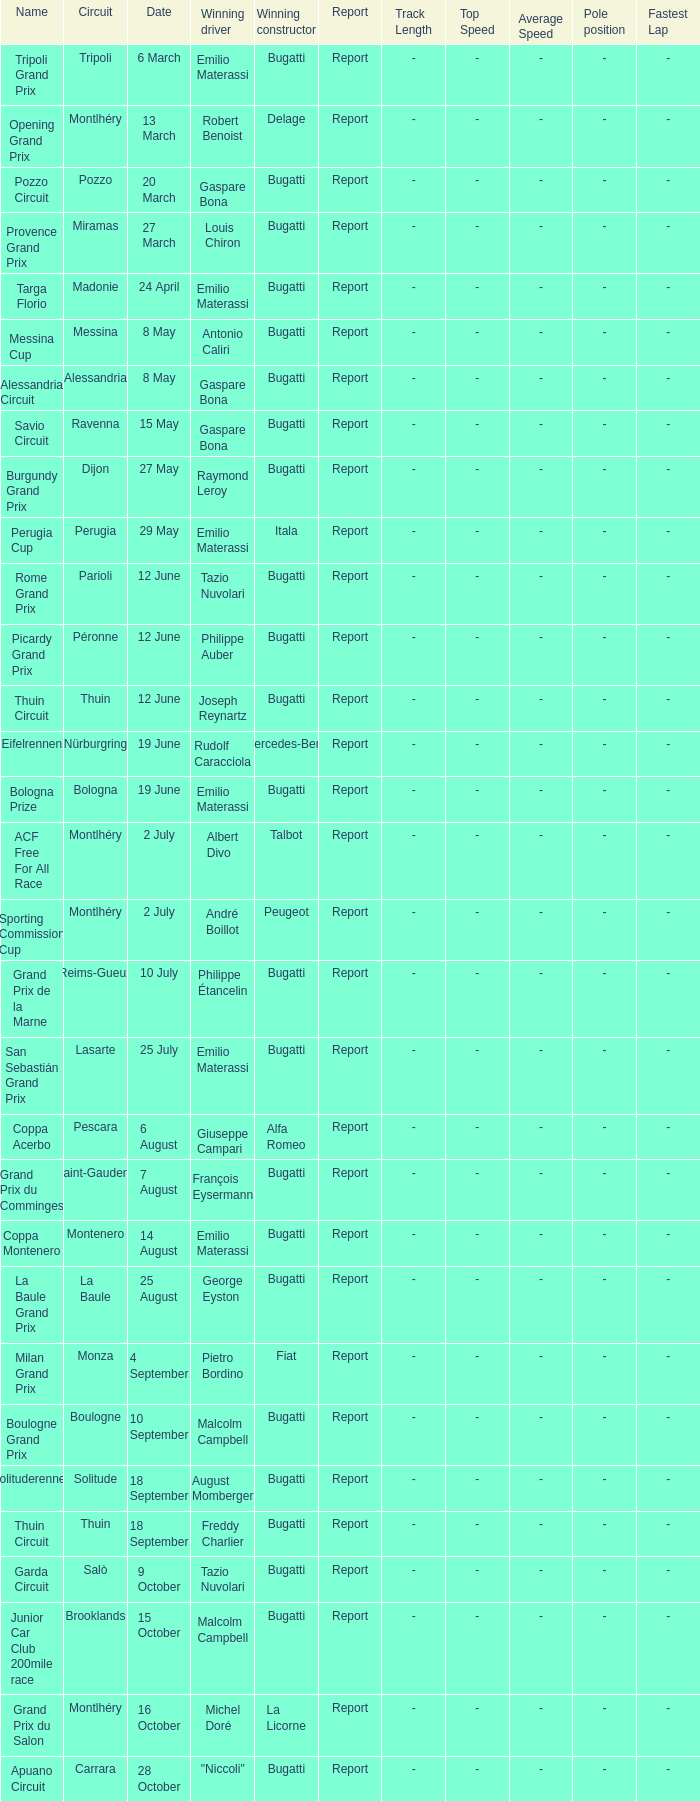Parse the full table. {'header': ['Name', 'Circuit', 'Date', 'Winning driver', 'Winning constructor', 'Report', 'Track Length', 'Top Speed', 'Average Speed', 'Pole position', 'Fastest Lap'], 'rows': [['Tripoli Grand Prix', 'Tripoli', '6 March', 'Emilio Materassi', 'Bugatti', 'Report', '-', '-', '-', '-', '-'], ['Opening Grand Prix', 'Montlhéry', '13 March', 'Robert Benoist', 'Delage', 'Report', '-', '-', '-', '-', '-'], ['Pozzo Circuit', 'Pozzo', '20 March', 'Gaspare Bona', 'Bugatti', 'Report', '-', '-', '-', '-', '-'], ['Provence Grand Prix', 'Miramas', '27 March', 'Louis Chiron', 'Bugatti', 'Report', '-', '-', '-', '-', '-'], ['Targa Florio', 'Madonie', '24 April', 'Emilio Materassi', 'Bugatti', 'Report', '-', '-', '-', '-', '-'], ['Messina Cup', 'Messina', '8 May', 'Antonio Caliri', 'Bugatti', 'Report', '-', '-', '-', '-', '-'], ['Alessandria Circuit', 'Alessandria', '8 May', 'Gaspare Bona', 'Bugatti', 'Report', '-', '-', '-', '-', '-'], ['Savio Circuit', 'Ravenna', '15 May', 'Gaspare Bona', 'Bugatti', 'Report', '-', '-', '-', '-', '-'], ['Burgundy Grand Prix', 'Dijon', '27 May', 'Raymond Leroy', 'Bugatti', 'Report', '-', '-', '-', '-', '-'], ['Perugia Cup', 'Perugia', '29 May', 'Emilio Materassi', 'Itala', 'Report', '-', '-', '-', '-', '-'], ['Rome Grand Prix', 'Parioli', '12 June', 'Tazio Nuvolari', 'Bugatti', 'Report', '-', '-', '-', '-', '-'], ['Picardy Grand Prix', 'Péronne', '12 June', 'Philippe Auber', 'Bugatti', 'Report', '-', '-', '-', '-', '-'], ['Thuin Circuit', 'Thuin', '12 June', 'Joseph Reynartz', 'Bugatti', 'Report', '-', '-', '-', '-', '-'], ['Eifelrennen', 'Nürburgring', '19 June', 'Rudolf Caracciola', 'Mercedes-Benz', 'Report', '-', '-', '-', '-', '-'], ['Bologna Prize', 'Bologna', '19 June', 'Emilio Materassi', 'Bugatti', 'Report', '-', '-', '-', '-', '-'], ['ACF Free For All Race', 'Montlhéry', '2 July', 'Albert Divo', 'Talbot', 'Report', '-', '-', '-', '-', '-'], ['Sporting Commission Cup', 'Montlhéry', '2 July', 'André Boillot', 'Peugeot', 'Report', '-', '-', '-', '-', '-'], ['Grand Prix de la Marne', 'Reims-Gueux', '10 July', 'Philippe Étancelin', 'Bugatti', 'Report', '-', '-', '-', '-', '-'], ['San Sebastián Grand Prix', 'Lasarte', '25 July', 'Emilio Materassi', 'Bugatti', 'Report', '-', '-', '-', '-', '-'], ['Coppa Acerbo', 'Pescara', '6 August', 'Giuseppe Campari', 'Alfa Romeo', 'Report', '-', '-', '-', '-', '-'], ['Grand Prix du Comminges', 'Saint-Gaudens', '7 August', 'François Eysermann', 'Bugatti', 'Report', '-', '-', '-', '-', '-'], ['Coppa Montenero', 'Montenero', '14 August', 'Emilio Materassi', 'Bugatti', 'Report', '-', '-', '-', '-', '-'], ['La Baule Grand Prix', 'La Baule', '25 August', 'George Eyston', 'Bugatti', 'Report', '-', '-', '-', '-', '-'], ['Milan Grand Prix', 'Monza', '4 September', 'Pietro Bordino', 'Fiat', 'Report', '-', '-', '-', '-', '-'], ['Boulogne Grand Prix', 'Boulogne', '10 September', 'Malcolm Campbell', 'Bugatti', 'Report', '-', '-', '-', '-', '-'], ['Solituderennen', 'Solitude', '18 September', 'August Momberger', 'Bugatti', 'Report', '-', '-', '-', '-', '-'], ['Thuin Circuit', 'Thuin', '18 September', 'Freddy Charlier', 'Bugatti', 'Report', '-', '-', '-', '-', '-'], ['Garda Circuit', 'Salò', '9 October', 'Tazio Nuvolari', 'Bugatti', 'Report', '-', '-', '-', '-', '-'], ['Junior Car Club 200mile race', 'Brooklands', '15 October', 'Malcolm Campbell', 'Bugatti', 'Report', '-', '-', '-', '-', '-'], ['Grand Prix du Salon', 'Montlhéry', '16 October', 'Michel Doré', 'La Licorne', 'Report', '-', '-', '-', '-', '-'], ['Apuano Circuit', 'Carrara', '28 October', '"Niccoli"', 'Bugatti', 'Report', '-', '-', '-', '-', '-']]} Which circuit did françois eysermann win ? Saint-Gaudens. 